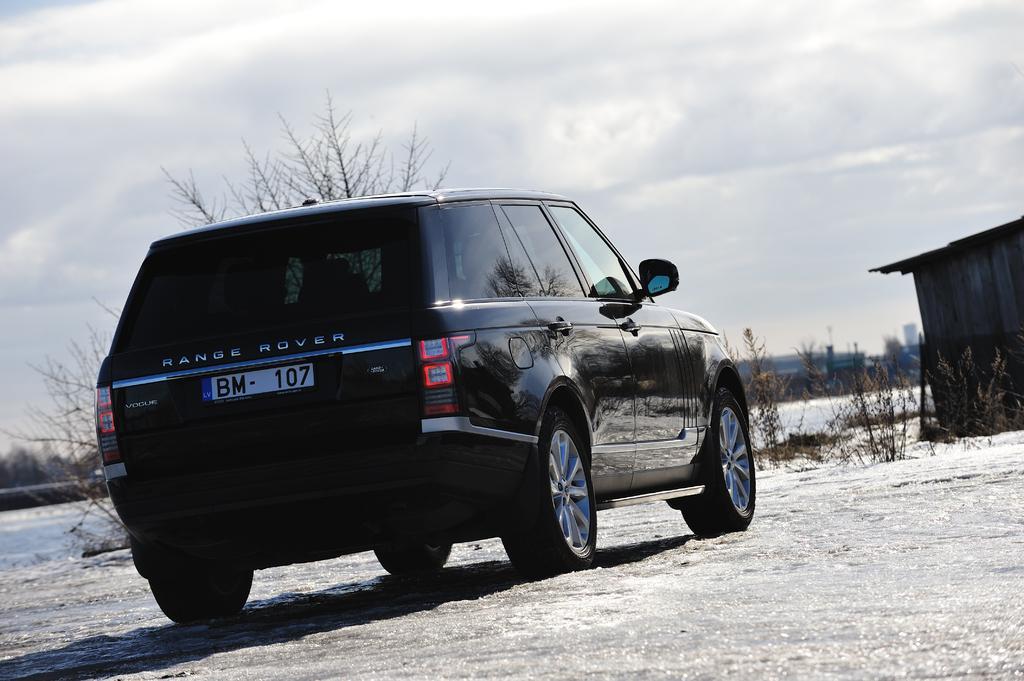Describe this image in one or two sentences. In this image we can see one car on the ground, some trees, bushes, one shed, some objects on the ground, plants and grass on the ground. At the top there is the sky. 